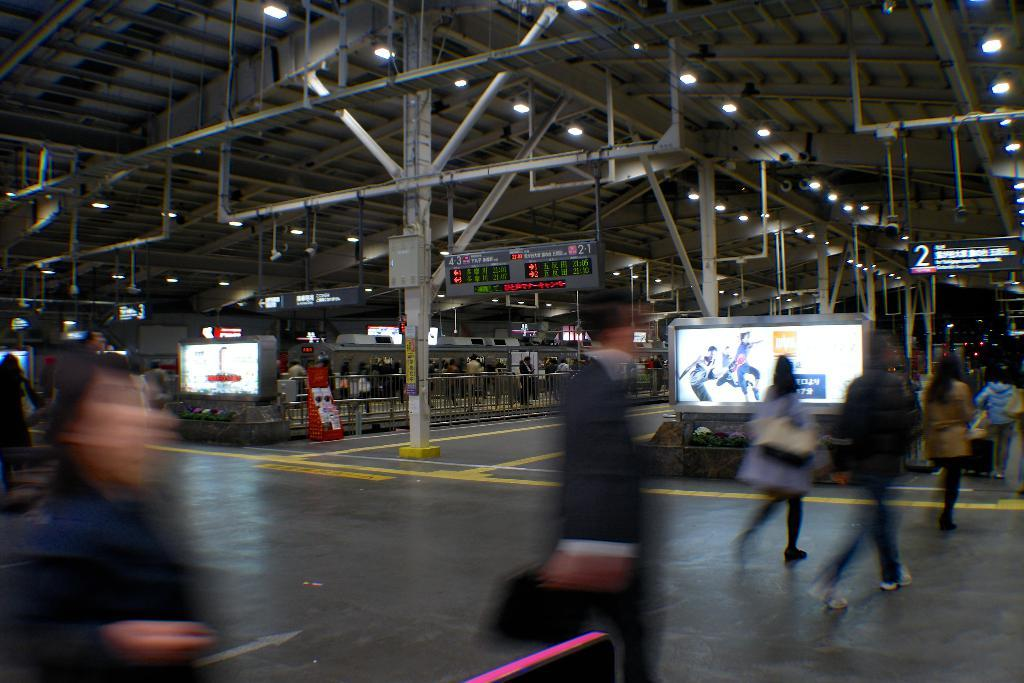What is located on the right side of the image? There is a screen on the right side of the image. What are the people near the screen doing? People are walking near the screen. What can be seen in the middle of the image? There is a pillar in the middle of the image. What is the pillar made up of? The pillar is made up of some material. Can you see any waves in the image? There are no waves present in the image. What type of wood is used to construct the floor in the image? There is no mention of a floor in the image, so it is not possible to determine the type of wood used. 